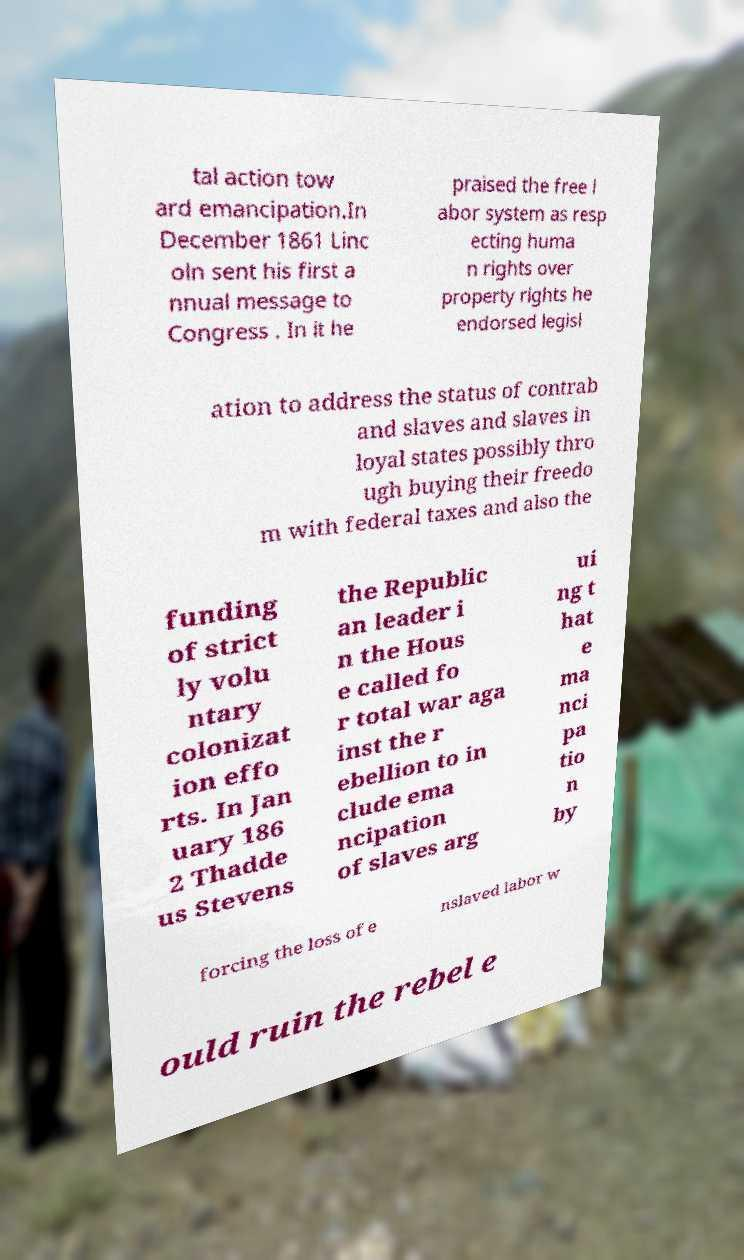Can you accurately transcribe the text from the provided image for me? tal action tow ard emancipation.In December 1861 Linc oln sent his first a nnual message to Congress . In it he praised the free l abor system as resp ecting huma n rights over property rights he endorsed legisl ation to address the status of contrab and slaves and slaves in loyal states possibly thro ugh buying their freedo m with federal taxes and also the funding of strict ly volu ntary colonizat ion effo rts. In Jan uary 186 2 Thadde us Stevens the Republic an leader i n the Hous e called fo r total war aga inst the r ebellion to in clude ema ncipation of slaves arg ui ng t hat e ma nci pa tio n by forcing the loss of e nslaved labor w ould ruin the rebel e 